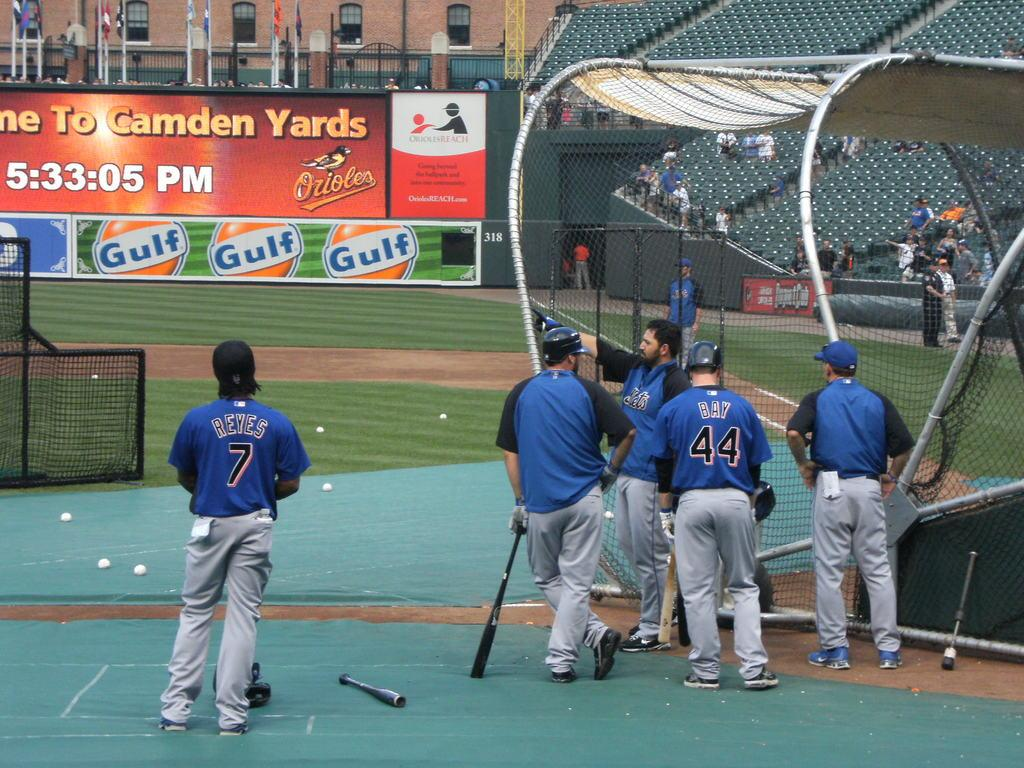<image>
Give a short and clear explanation of the subsequent image. A baseball field has a banner that contains a logo for "Gulf." 